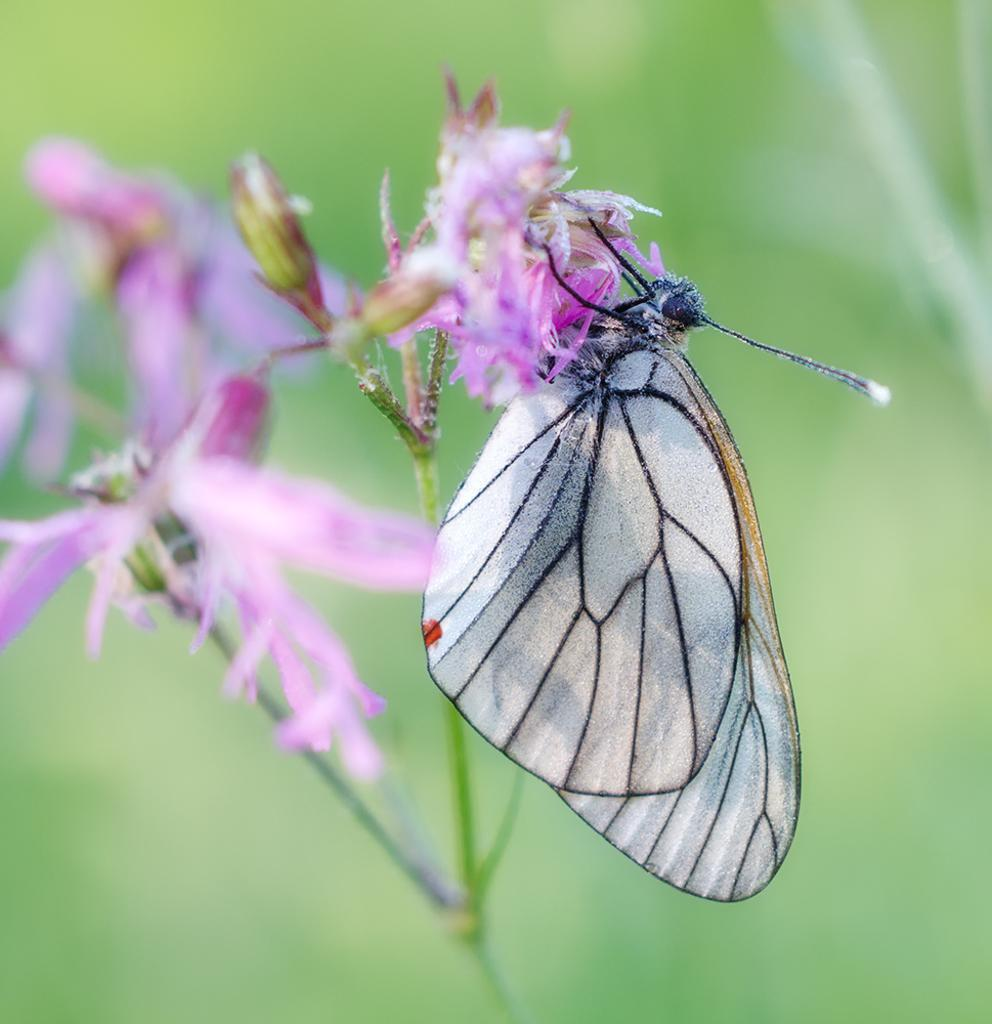What is the main subject of the image? There is a butterfly in the image. Where is the butterfly located? The butterfly is on a flower. What color is the flower? The flower is purple. What color is the background of the image? The background of the image is green. What type of steel is used to construct the toad in the image? There is no toad present in the image, and therefore no steel construction can be observed. 